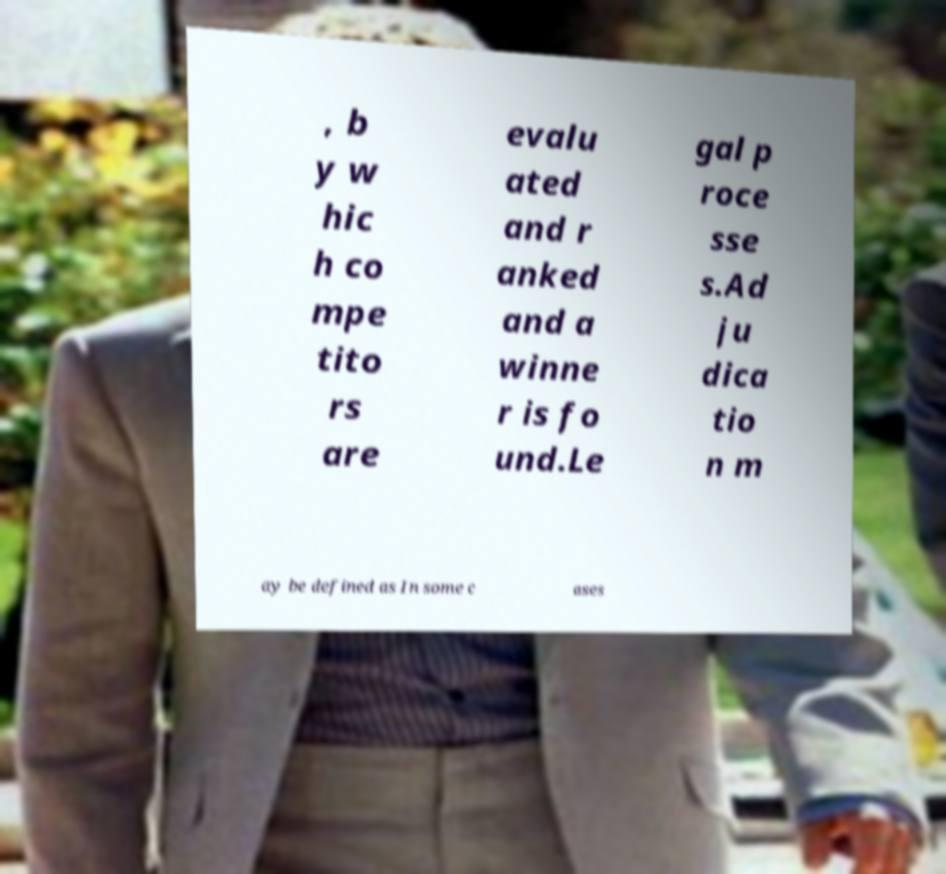For documentation purposes, I need the text within this image transcribed. Could you provide that? , b y w hic h co mpe tito rs are evalu ated and r anked and a winne r is fo und.Le gal p roce sse s.Ad ju dica tio n m ay be defined as In some c ases 